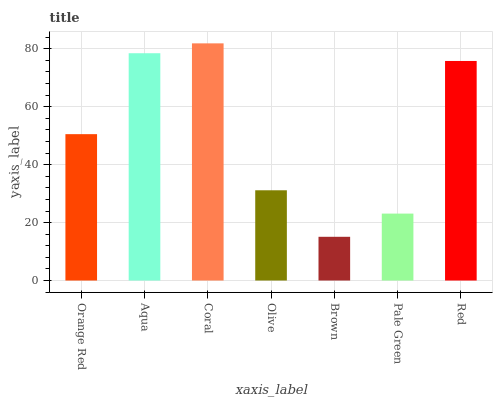Is Brown the minimum?
Answer yes or no. Yes. Is Coral the maximum?
Answer yes or no. Yes. Is Aqua the minimum?
Answer yes or no. No. Is Aqua the maximum?
Answer yes or no. No. Is Aqua greater than Orange Red?
Answer yes or no. Yes. Is Orange Red less than Aqua?
Answer yes or no. Yes. Is Orange Red greater than Aqua?
Answer yes or no. No. Is Aqua less than Orange Red?
Answer yes or no. No. Is Orange Red the high median?
Answer yes or no. Yes. Is Orange Red the low median?
Answer yes or no. Yes. Is Coral the high median?
Answer yes or no. No. Is Pale Green the low median?
Answer yes or no. No. 